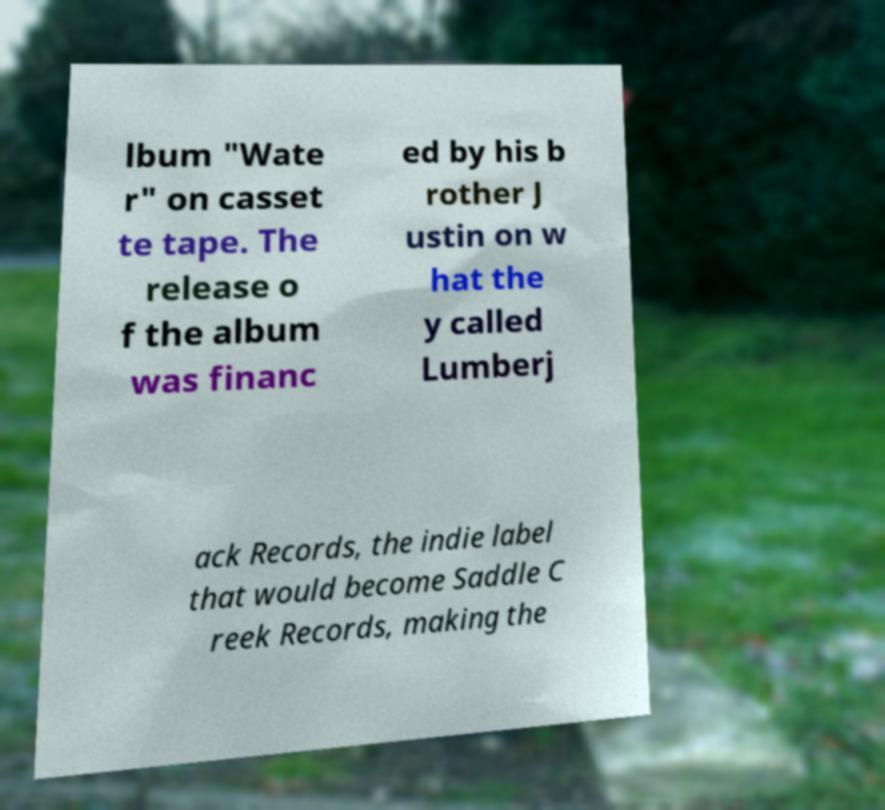I need the written content from this picture converted into text. Can you do that? lbum "Wate r" on casset te tape. The release o f the album was financ ed by his b rother J ustin on w hat the y called Lumberj ack Records, the indie label that would become Saddle C reek Records, making the 